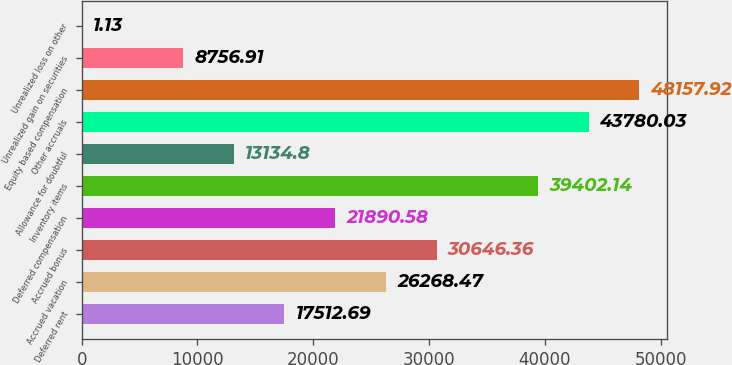Convert chart. <chart><loc_0><loc_0><loc_500><loc_500><bar_chart><fcel>Deferred rent<fcel>Accrued vacation<fcel>Accrued bonus<fcel>Deferred compensation<fcel>Inventory items<fcel>Allowance for doubtful<fcel>Other accruals<fcel>Equity based compensation<fcel>Unrealized gain on securities<fcel>Unrealized loss on other<nl><fcel>17512.7<fcel>26268.5<fcel>30646.4<fcel>21890.6<fcel>39402.1<fcel>13134.8<fcel>43780<fcel>48157.9<fcel>8756.91<fcel>1.13<nl></chart> 